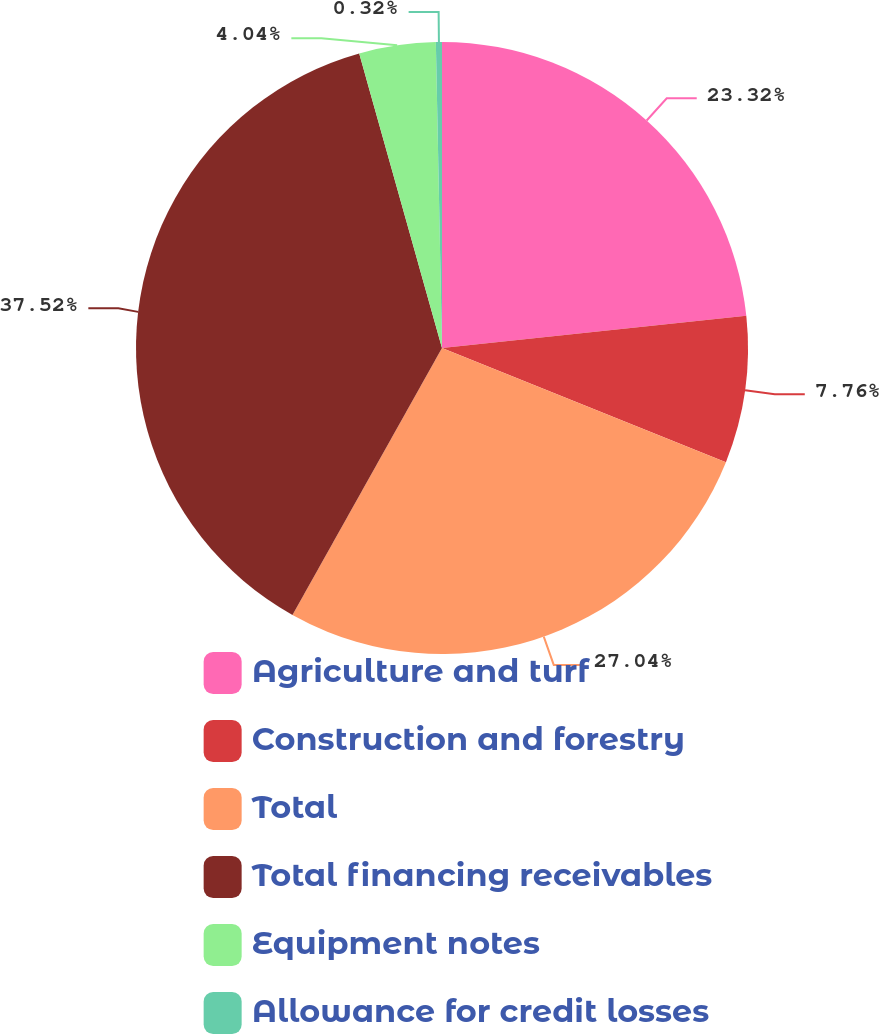<chart> <loc_0><loc_0><loc_500><loc_500><pie_chart><fcel>Agriculture and turf<fcel>Construction and forestry<fcel>Total<fcel>Total financing receivables<fcel>Equipment notes<fcel>Allowance for credit losses<nl><fcel>23.32%<fcel>7.76%<fcel>27.04%<fcel>37.51%<fcel>4.04%<fcel>0.32%<nl></chart> 